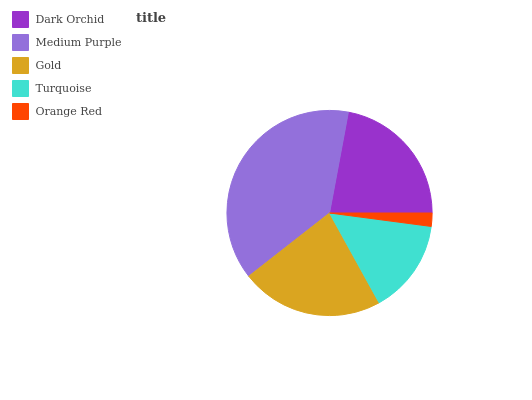Is Orange Red the minimum?
Answer yes or no. Yes. Is Medium Purple the maximum?
Answer yes or no. Yes. Is Gold the minimum?
Answer yes or no. No. Is Gold the maximum?
Answer yes or no. No. Is Medium Purple greater than Gold?
Answer yes or no. Yes. Is Gold less than Medium Purple?
Answer yes or no. Yes. Is Gold greater than Medium Purple?
Answer yes or no. No. Is Medium Purple less than Gold?
Answer yes or no. No. Is Dark Orchid the high median?
Answer yes or no. Yes. Is Dark Orchid the low median?
Answer yes or no. Yes. Is Turquoise the high median?
Answer yes or no. No. Is Medium Purple the low median?
Answer yes or no. No. 